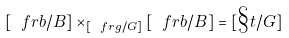<formula> <loc_0><loc_0><loc_500><loc_500>[ \ f r b / B ] \times _ { [ \ f r g / G ] } [ \ f r b / B ] = [ \S t / G ]</formula> 